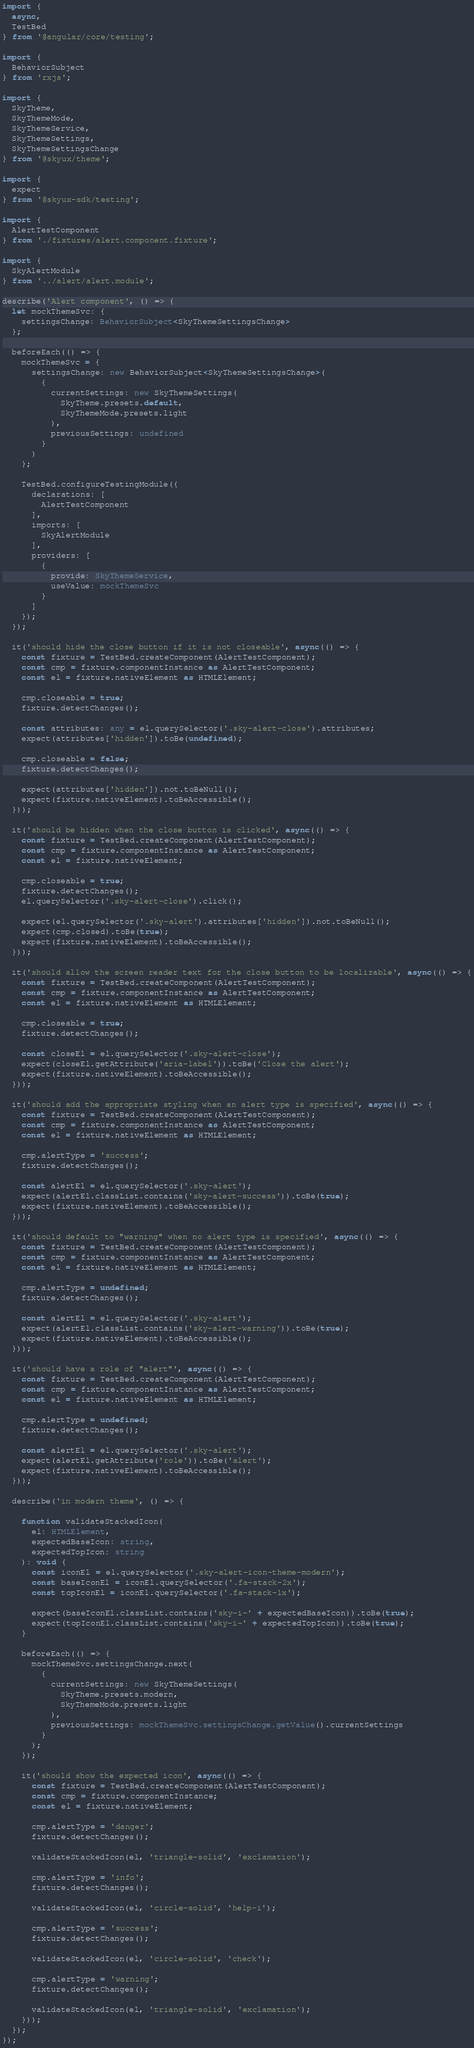<code> <loc_0><loc_0><loc_500><loc_500><_TypeScript_>import {
  async,
  TestBed
} from '@angular/core/testing';

import {
  BehaviorSubject
} from 'rxjs';

import {
  SkyTheme,
  SkyThemeMode,
  SkyThemeService,
  SkyThemeSettings,
  SkyThemeSettingsChange
} from '@skyux/theme';

import {
  expect
} from '@skyux-sdk/testing';

import {
  AlertTestComponent
} from './fixtures/alert.component.fixture';

import {
  SkyAlertModule
} from '../alert/alert.module';

describe('Alert component', () => {
  let mockThemeSvc: {
    settingsChange: BehaviorSubject<SkyThemeSettingsChange>
  };

  beforeEach(() => {
    mockThemeSvc = {
      settingsChange: new BehaviorSubject<SkyThemeSettingsChange>(
        {
          currentSettings: new SkyThemeSettings(
            SkyTheme.presets.default,
            SkyThemeMode.presets.light
          ),
          previousSettings: undefined
        }
      )
    };

    TestBed.configureTestingModule({
      declarations: [
        AlertTestComponent
      ],
      imports: [
        SkyAlertModule
      ],
      providers: [
        {
          provide: SkyThemeService,
          useValue: mockThemeSvc
        }
      ]
    });
  });

  it('should hide the close button if it is not closeable', async(() => {
    const fixture = TestBed.createComponent(AlertTestComponent);
    const cmp = fixture.componentInstance as AlertTestComponent;
    const el = fixture.nativeElement as HTMLElement;

    cmp.closeable = true;
    fixture.detectChanges();

    const attributes: any = el.querySelector('.sky-alert-close').attributes;
    expect(attributes['hidden']).toBe(undefined);

    cmp.closeable = false;
    fixture.detectChanges();

    expect(attributes['hidden']).not.toBeNull();
    expect(fixture.nativeElement).toBeAccessible();
  }));

  it('should be hidden when the close button is clicked', async(() => {
    const fixture = TestBed.createComponent(AlertTestComponent);
    const cmp = fixture.componentInstance as AlertTestComponent;
    const el = fixture.nativeElement;

    cmp.closeable = true;
    fixture.detectChanges();
    el.querySelector('.sky-alert-close').click();

    expect(el.querySelector('.sky-alert').attributes['hidden']).not.toBeNull();
    expect(cmp.closed).toBe(true);
    expect(fixture.nativeElement).toBeAccessible();
  }));

  it('should allow the screen reader text for the close button to be localizable', async(() => {
    const fixture = TestBed.createComponent(AlertTestComponent);
    const cmp = fixture.componentInstance as AlertTestComponent;
    const el = fixture.nativeElement as HTMLElement;

    cmp.closeable = true;
    fixture.detectChanges();

    const closeEl = el.querySelector('.sky-alert-close');
    expect(closeEl.getAttribute('aria-label')).toBe('Close the alert');
    expect(fixture.nativeElement).toBeAccessible();
  }));

  it('should add the appropriate styling when an alert type is specified', async(() => {
    const fixture = TestBed.createComponent(AlertTestComponent);
    const cmp = fixture.componentInstance as AlertTestComponent;
    const el = fixture.nativeElement as HTMLElement;

    cmp.alertType = 'success';
    fixture.detectChanges();

    const alertEl = el.querySelector('.sky-alert');
    expect(alertEl.classList.contains('sky-alert-success')).toBe(true);
    expect(fixture.nativeElement).toBeAccessible();
  }));

  it('should default to "warning" when no alert type is specified', async(() => {
    const fixture = TestBed.createComponent(AlertTestComponent);
    const cmp = fixture.componentInstance as AlertTestComponent;
    const el = fixture.nativeElement as HTMLElement;

    cmp.alertType = undefined;
    fixture.detectChanges();

    const alertEl = el.querySelector('.sky-alert');
    expect(alertEl.classList.contains('sky-alert-warning')).toBe(true);
    expect(fixture.nativeElement).toBeAccessible();
  }));

  it('should have a role of "alert"', async(() => {
    const fixture = TestBed.createComponent(AlertTestComponent);
    const cmp = fixture.componentInstance as AlertTestComponent;
    const el = fixture.nativeElement as HTMLElement;

    cmp.alertType = undefined;
    fixture.detectChanges();

    const alertEl = el.querySelector('.sky-alert');
    expect(alertEl.getAttribute('role')).toBe('alert');
    expect(fixture.nativeElement).toBeAccessible();
  }));

  describe('in modern theme', () => {

    function validateStackedIcon(
      el: HTMLElement,
      expectedBaseIcon: string,
      expectedTopIcon: string
    ): void {
      const iconEl = el.querySelector('.sky-alert-icon-theme-modern');
      const baseIconEl = iconEl.querySelector('.fa-stack-2x');
      const topIconEl = iconEl.querySelector('.fa-stack-1x');

      expect(baseIconEl.classList.contains('sky-i-' + expectedBaseIcon)).toBe(true);
      expect(topIconEl.classList.contains('sky-i-' + expectedTopIcon)).toBe(true);
    }

    beforeEach(() => {
      mockThemeSvc.settingsChange.next(
        {
          currentSettings: new SkyThemeSettings(
            SkyTheme.presets.modern,
            SkyThemeMode.presets.light
          ),
          previousSettings: mockThemeSvc.settingsChange.getValue().currentSettings
        }
      );
    });

    it('should show the expected icon', async(() => {
      const fixture = TestBed.createComponent(AlertTestComponent);
      const cmp = fixture.componentInstance;
      const el = fixture.nativeElement;

      cmp.alertType = 'danger';
      fixture.detectChanges();

      validateStackedIcon(el, 'triangle-solid', 'exclamation');

      cmp.alertType = 'info';
      fixture.detectChanges();

      validateStackedIcon(el, 'circle-solid', 'help-i');

      cmp.alertType = 'success';
      fixture.detectChanges();

      validateStackedIcon(el, 'circle-solid', 'check');

      cmp.alertType = 'warning';
      fixture.detectChanges();

      validateStackedIcon(el, 'triangle-solid', 'exclamation');
    }));
  });
});
</code> 